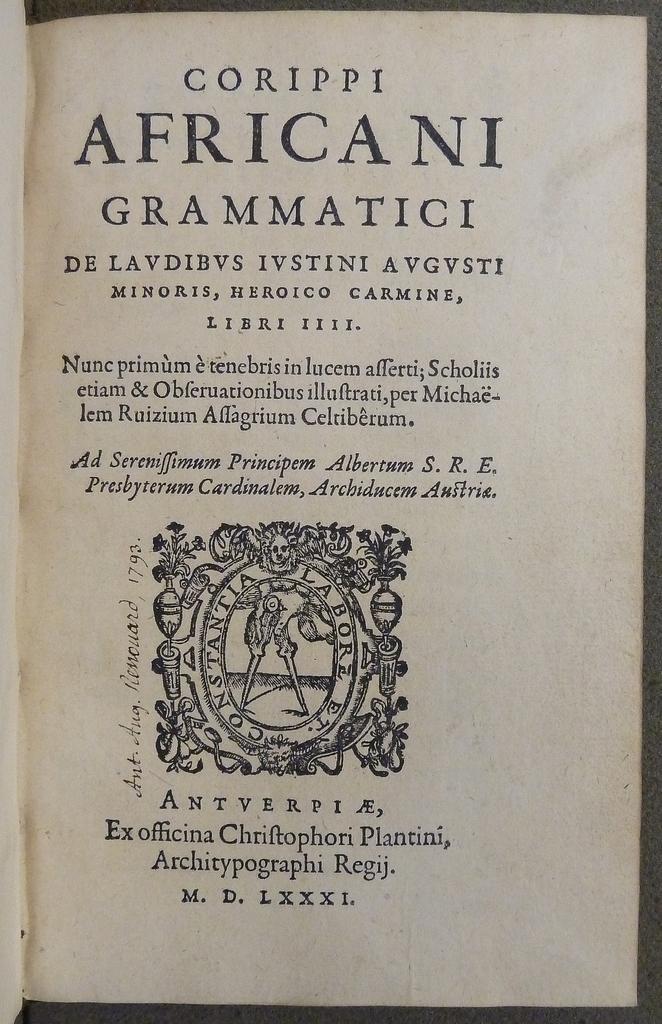<image>
Describe the image concisely. A book is open to the title page which says Corippi Africani Grammatici. 